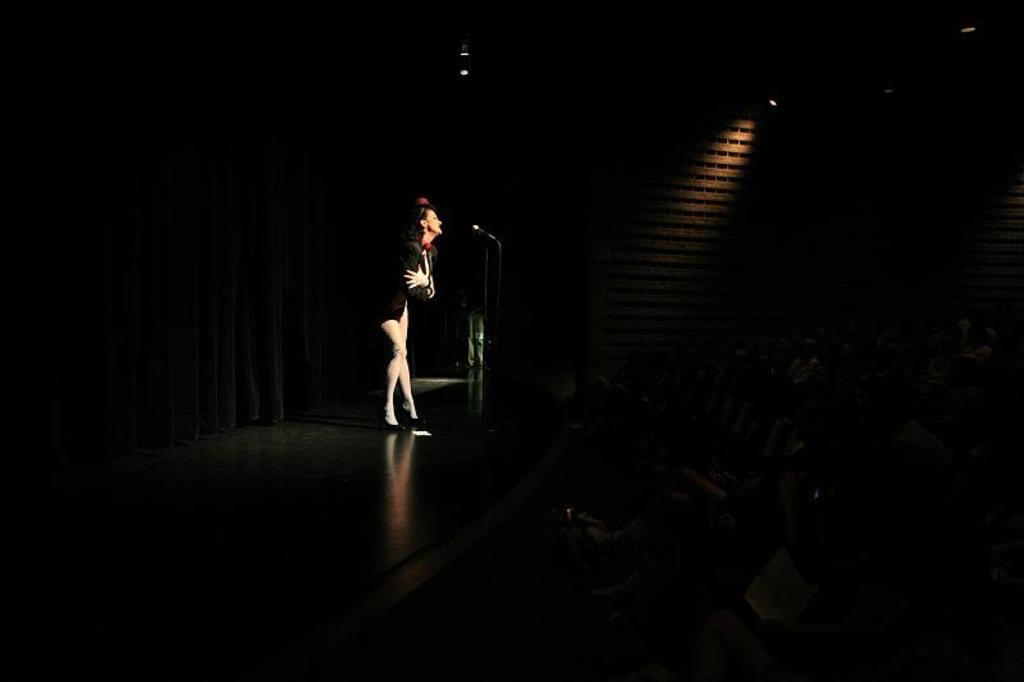Who is the main subject in the image? There is a woman in the image. Can you describe the woman's appearance? The woman is beautiful. What is the woman doing in the image? The woman is standing and singing. What is the woman wearing in the image? The woman is wearing a black dress. What type of quiver is the woman holding in the image? There is no quiver present in the image; the woman is wearing a black dress and singing. How does the pest affect the woman's performance in the image? There is no mention of a pest in the image, and the woman is singing without any apparent disturbance. 